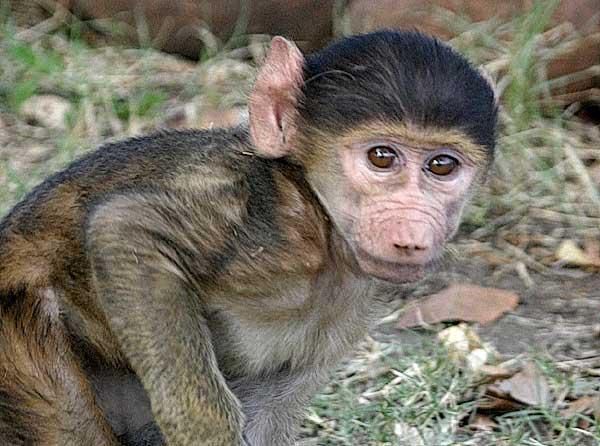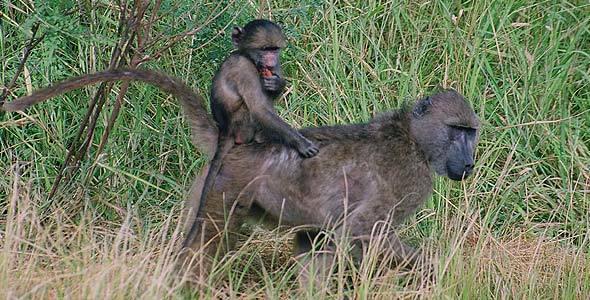The first image is the image on the left, the second image is the image on the right. Analyze the images presented: Is the assertion "There are three monkeys." valid? Answer yes or no. Yes. The first image is the image on the left, the second image is the image on the right. Analyze the images presented: Is the assertion "In the image on the left, a mother carries her baby." valid? Answer yes or no. No. 